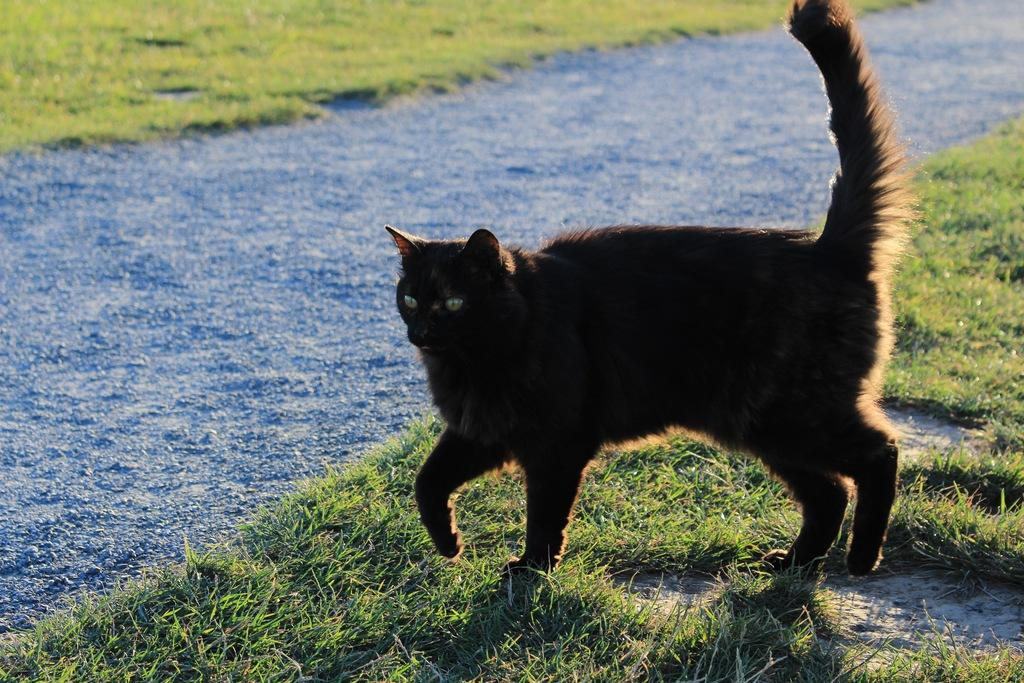What type of animal is in the image? There is a black color cat in the image. What is the cat doing in the image? The cat is walking on the grass. What can be seen on the ground in the image? There are stones on the ground in the image. Is there any issue with the image's clarity? Yes, the image is slightly blurred in the mentioned part. Can you see any fairies flying around the cat in the image? No, there are no fairies present in the image. What type of connection is the cat using to communicate with others in the image? The cat is not using any connection to communicate in the image, as it is a real-life animal. 